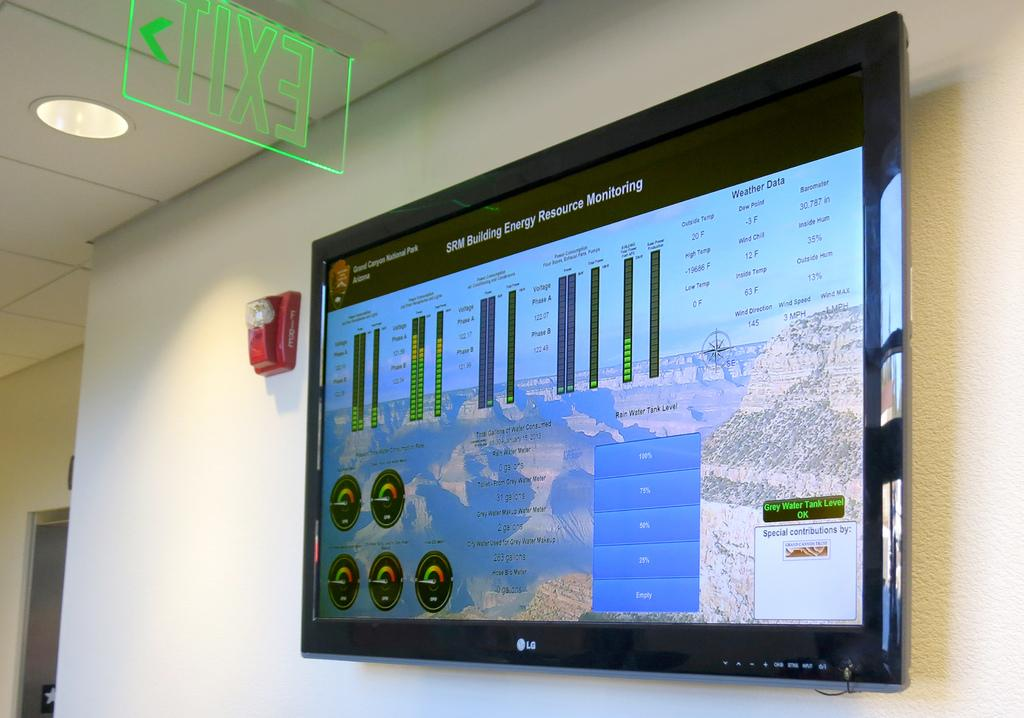Provide a one-sentence caption for the provided image. a monitor hangs on the wall showing information from the Grand Canyon National Park. 